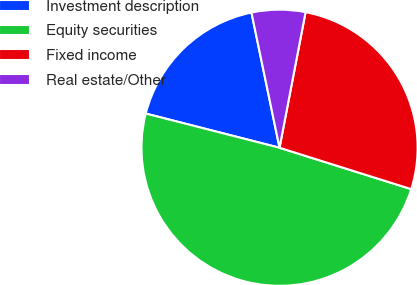Convert chart to OTSL. <chart><loc_0><loc_0><loc_500><loc_500><pie_chart><fcel>Investment description<fcel>Equity securities<fcel>Fixed income<fcel>Real estate/Other<nl><fcel>17.76%<fcel>49.14%<fcel>26.83%<fcel>6.28%<nl></chart> 